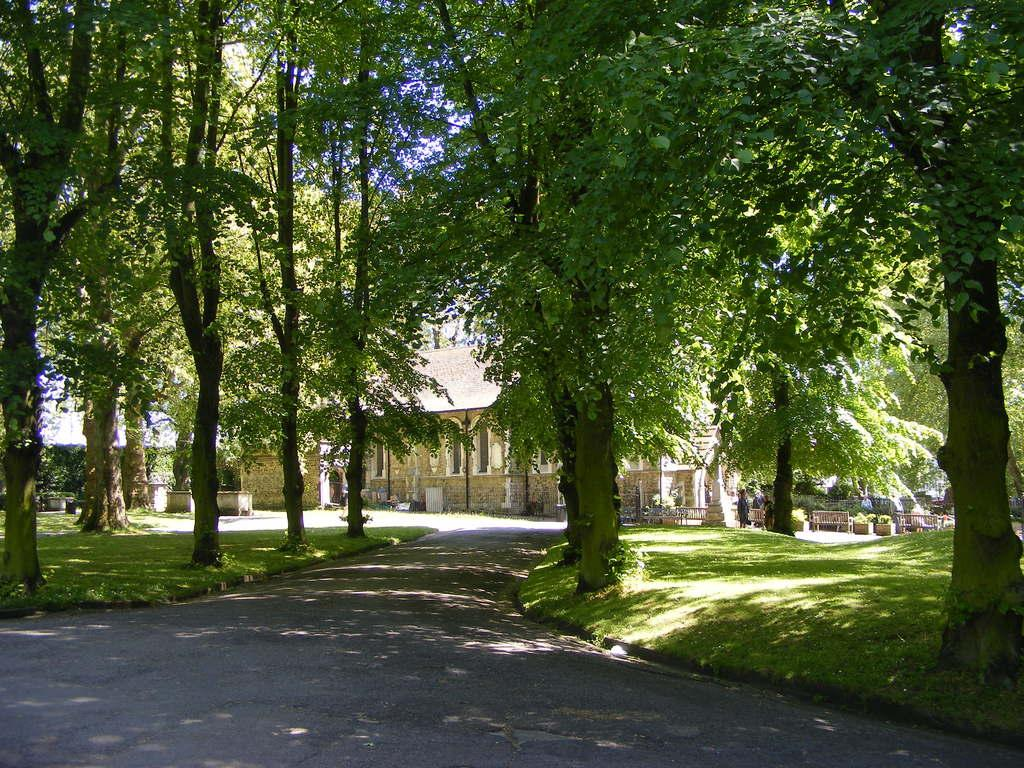What type of structure can be seen in the background of the image? There is a house in the background of the image. Who or what else can be seen in the background of the image? There are people and benches visible in the background of the image. What type of vegetation is present in the image? There are plants and trees in the image. What is the color of the grass in the image? There is green grass in the image. What type of pathway is visible in the image? There is a road in the image. What is the temper of the people in the image? There is no information about the temper of the people in the image. What is the aftermath of the event in the image? There is no event mentioned in the image, so it is not possible to discuss the aftermath. 